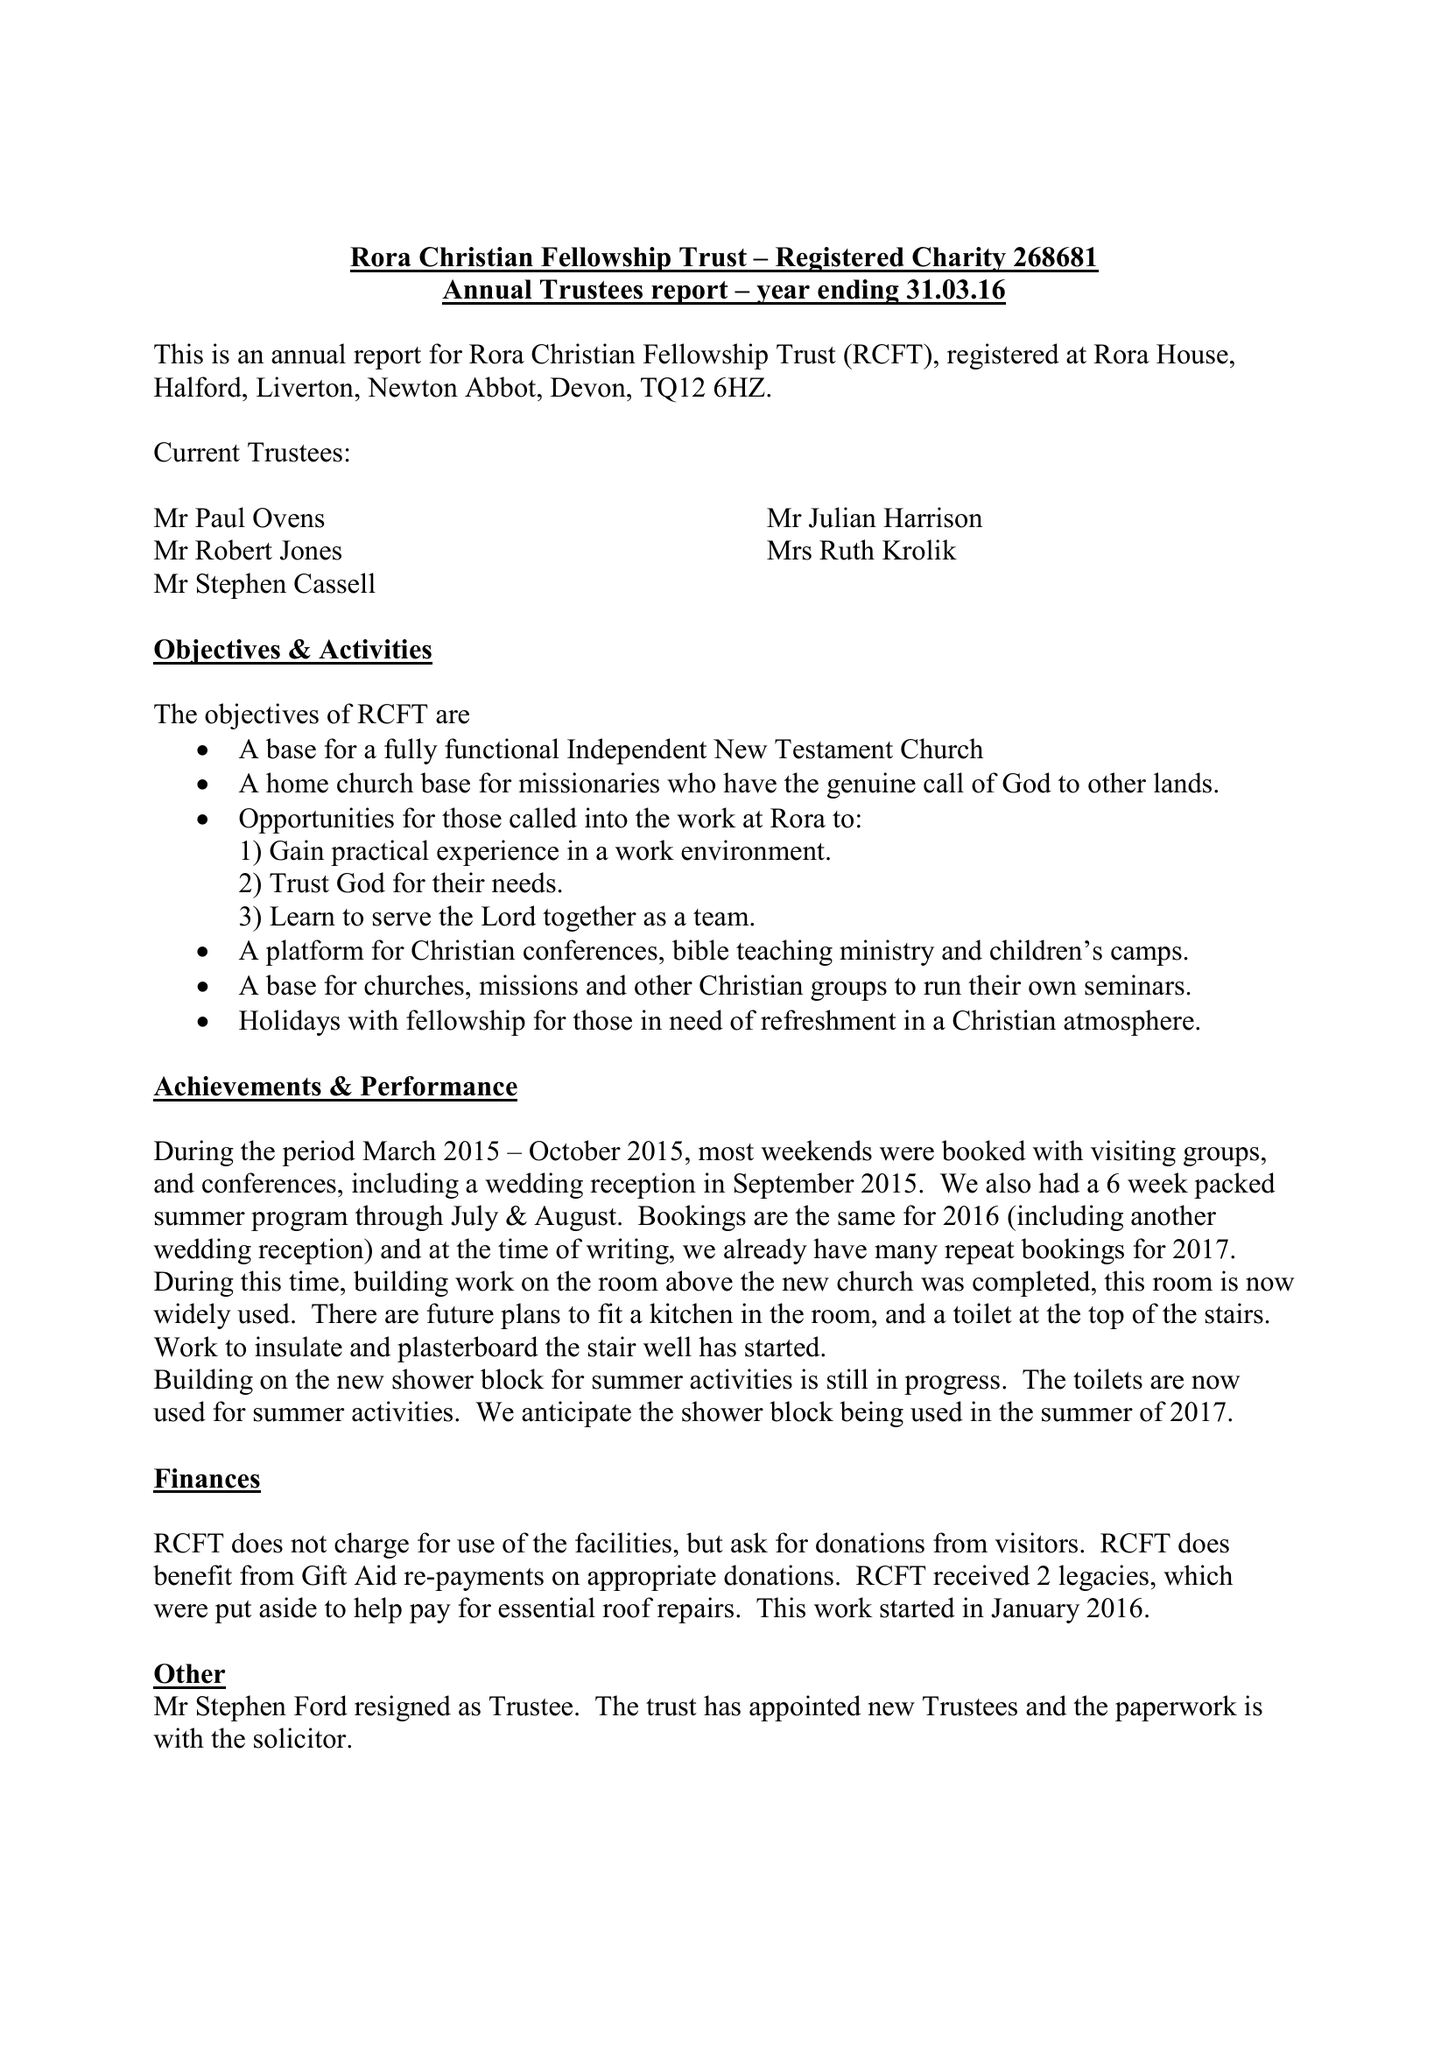What is the value for the spending_annually_in_british_pounds?
Answer the question using a single word or phrase. 96386.00 